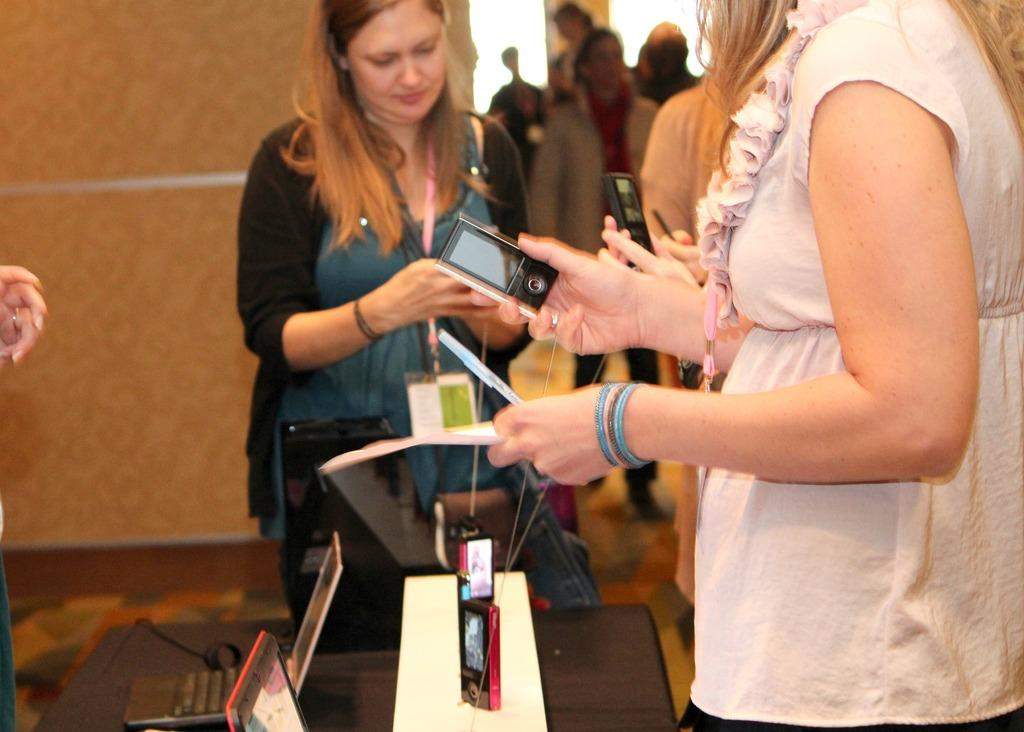Who is present in the image? There are women in the image. What are the women holding in their hands? The women are holding Ipods in their hands. What is in front of the women? There is a table in front of the women. What electronic devices can be seen on the table? There are laptops on the table. What can be seen in the background of the image? There is a wall in the background of the image. Can you tell me how many cards are being played by the men in the image? There are no men present in the image, and no cards are visible. 